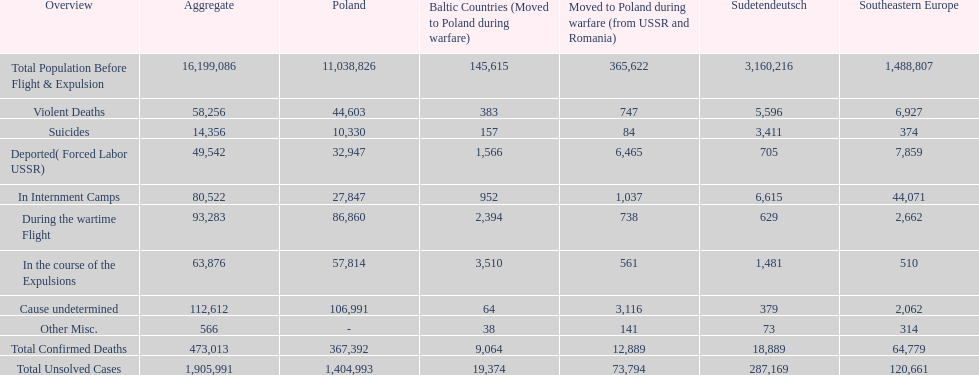What is the overall number of fatalities in detention centers and throughout the wartime escape? 173,805. 